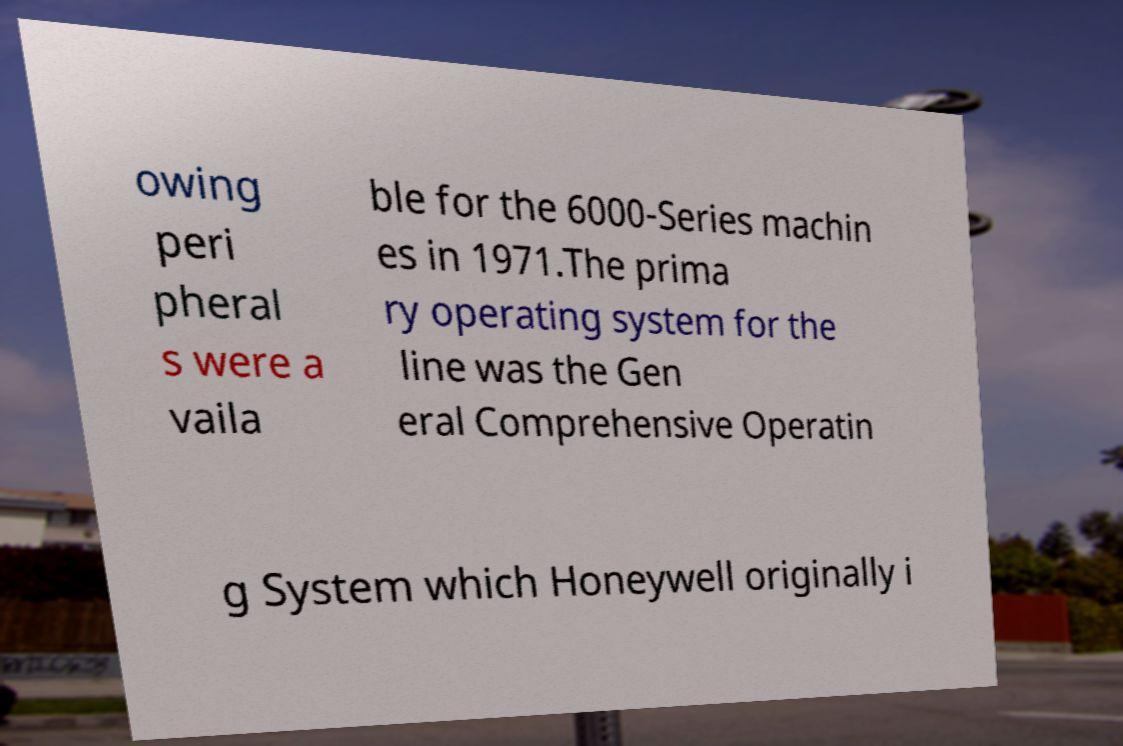Can you accurately transcribe the text from the provided image for me? owing peri pheral s were a vaila ble for the 6000-Series machin es in 1971.The prima ry operating system for the line was the Gen eral Comprehensive Operatin g System which Honeywell originally i 